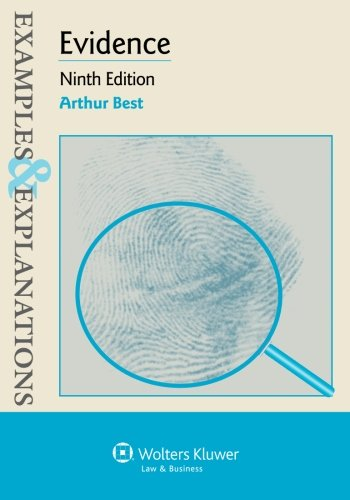Who is the author of this book? The author of the book is Arthur Best, known for his contributions to the field of law through educational materials. 